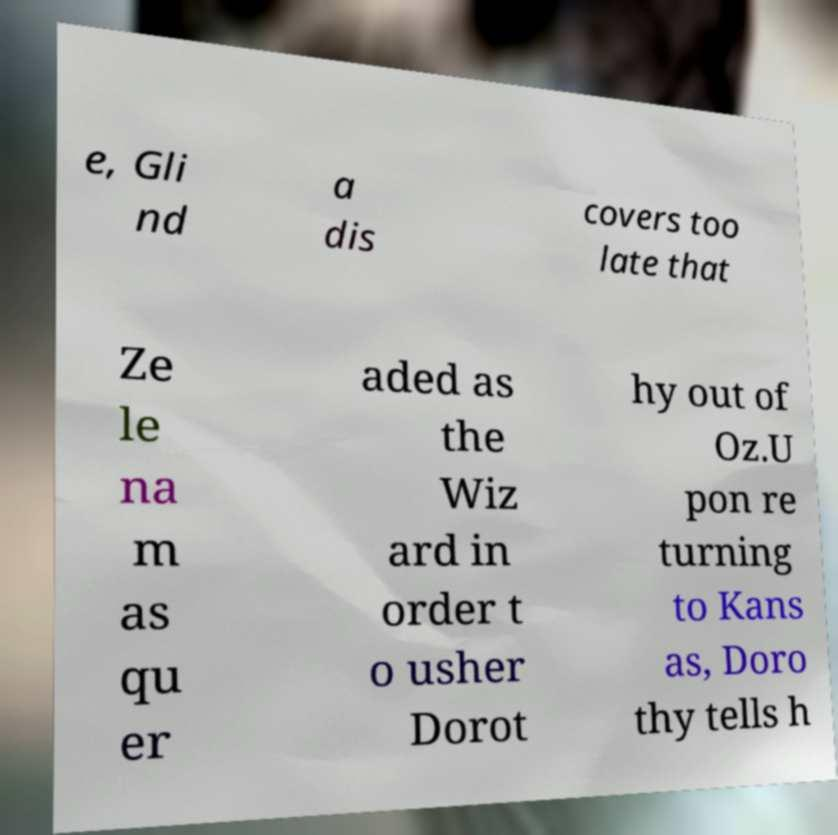There's text embedded in this image that I need extracted. Can you transcribe it verbatim? e, Gli nd a dis covers too late that Ze le na m as qu er aded as the Wiz ard in order t o usher Dorot hy out of Oz.U pon re turning to Kans as, Doro thy tells h 